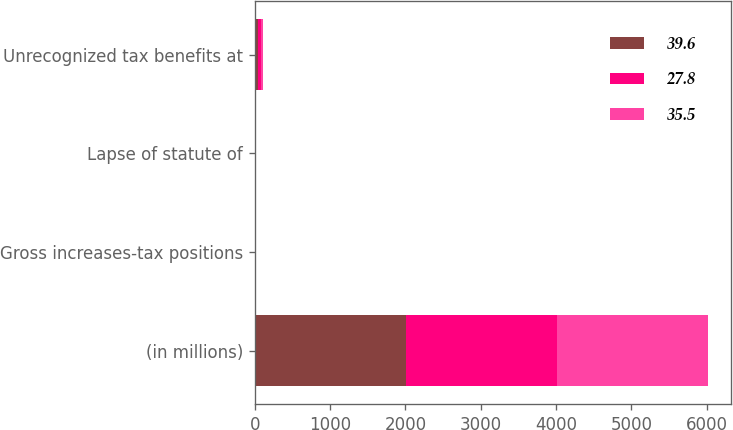Convert chart to OTSL. <chart><loc_0><loc_0><loc_500><loc_500><stacked_bar_chart><ecel><fcel>(in millions)<fcel>Gross increases-tax positions<fcel>Lapse of statute of<fcel>Unrecognized tax benefits at<nl><fcel>39.6<fcel>2009<fcel>10.1<fcel>0.2<fcel>39.6<nl><fcel>27.8<fcel>2008<fcel>0.5<fcel>0.1<fcel>35.5<nl><fcel>35.5<fcel>2007<fcel>2.1<fcel>0.1<fcel>27.8<nl></chart> 